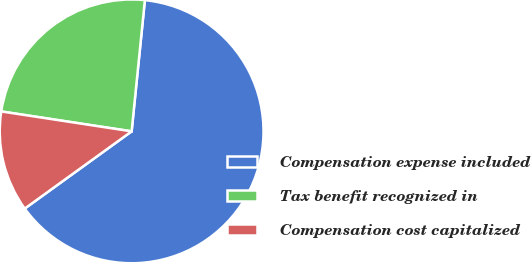Convert chart to OTSL. <chart><loc_0><loc_0><loc_500><loc_500><pie_chart><fcel>Compensation expense included<fcel>Tax benefit recognized in<fcel>Compensation cost capitalized<nl><fcel>63.44%<fcel>24.19%<fcel>12.37%<nl></chart> 